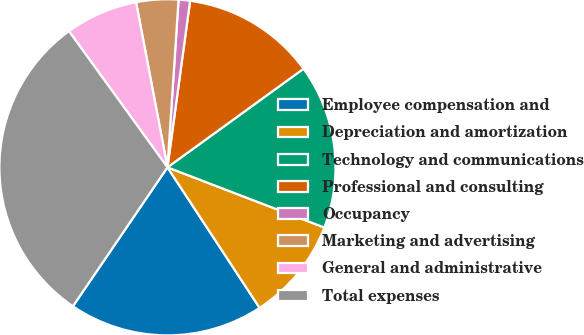Convert chart. <chart><loc_0><loc_0><loc_500><loc_500><pie_chart><fcel>Employee compensation and<fcel>Depreciation and amortization<fcel>Technology and communications<fcel>Professional and consulting<fcel>Occupancy<fcel>Marketing and advertising<fcel>General and administrative<fcel>Total expenses<nl><fcel>18.75%<fcel>9.93%<fcel>15.81%<fcel>12.87%<fcel>1.1%<fcel>4.04%<fcel>6.98%<fcel>30.52%<nl></chart> 